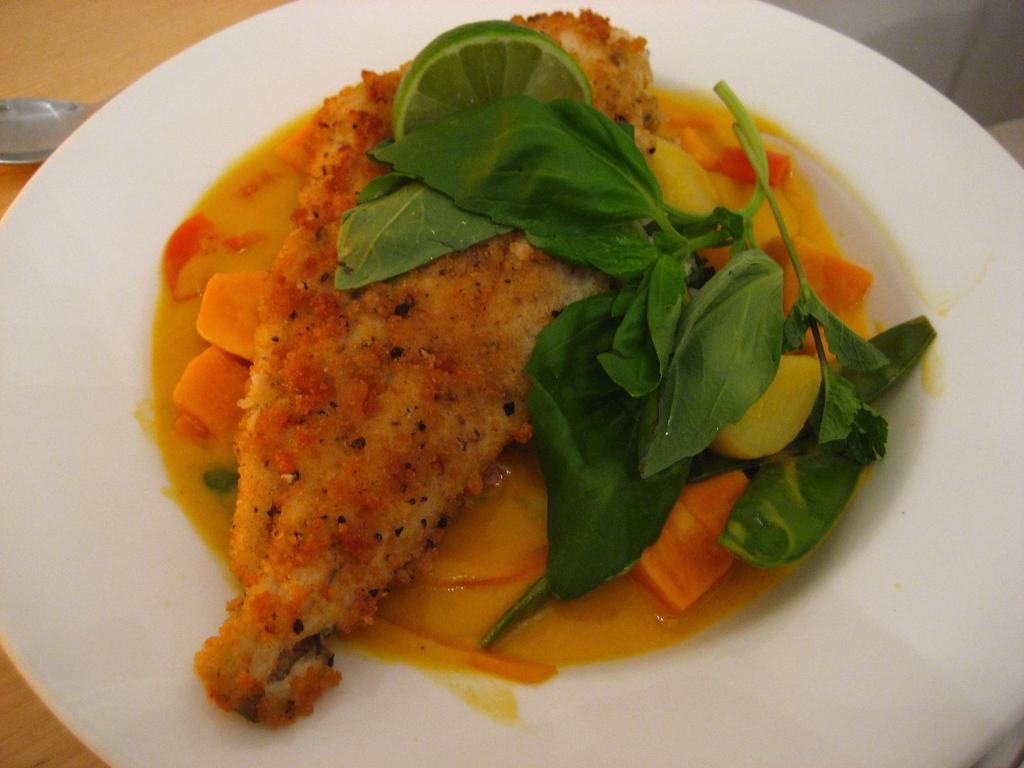What is the main object on the serving plate in the image? The serving plate contains cooked fish. Can you describe the type of food on the serving plate? The food on the serving plate is cooked fish. What type of meat is being transported by the train in the image? There is no train present in the image, and therefore no meat being transported. Is there a writer in the image working on a new novel? There is no writer or novel mentioned in the image. 